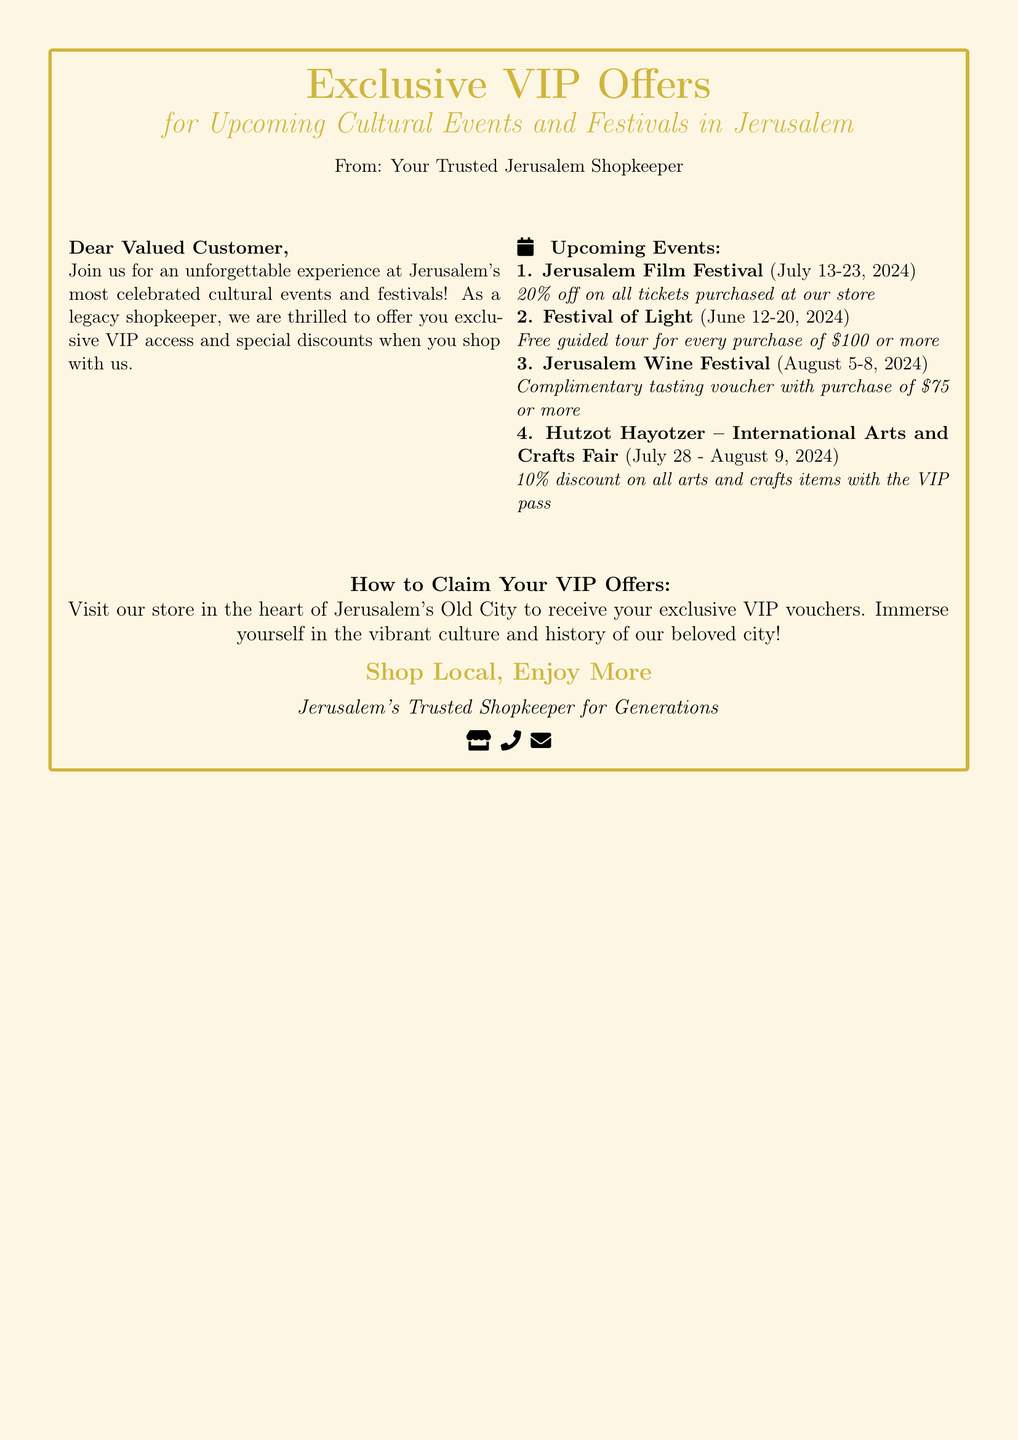what is the discount for the Jerusalem Film Festival? The document states a 20% discount on all tickets purchased at the store for the Jerusalem Film Festival.
Answer: 20% when does the Festival of Light take place? The document mentions that the Festival of Light occurs from June 12 to June 20, 2024.
Answer: June 12-20, 2024 what do you receive with a purchase of $100 or more during the Festival of Light? According to the document, you receive a free guided tour with a purchase of $100 or more during the Festival of Light.
Answer: Free guided tour how much do you need to spend to get a complimentary tasting voucher at the Jerusalem Wine Festival? The document specifies that you need to make a purchase of $75 or more to receive a complimentary tasting voucher at the Jerusalem Wine Festival.
Answer: $75 how much is the discount on arts and crafts items with the VIP pass at Hutzot Hayotzer? For the Hutzot Hayotzer – International Arts and Crafts Fair, the document indicates a 10% discount on all arts and crafts items with the VIP pass.
Answer: 10% where can you claim the VIP offers? The document states that you can claim your VIP offers at the shop located in the heart of Jerusalem's Old City.
Answer: At our store what is the primary purpose of this document? The document's main goal is to offer exclusive VIP access and discounts for upcoming cultural events and festivals in Jerusalem.
Answer: Exclusive VIP Offers who is the document addressed to? The document addresses "Dear Valued Customer" as the intended audience for VIP offers.
Answer: Dear Valued Customer what is the sentiment expressed by the shopkeeper in this document? The shopkeeper expresses excitement and a welcoming attitude towards offering exclusive VIP access to events.
Answer: Unforgettable experience 